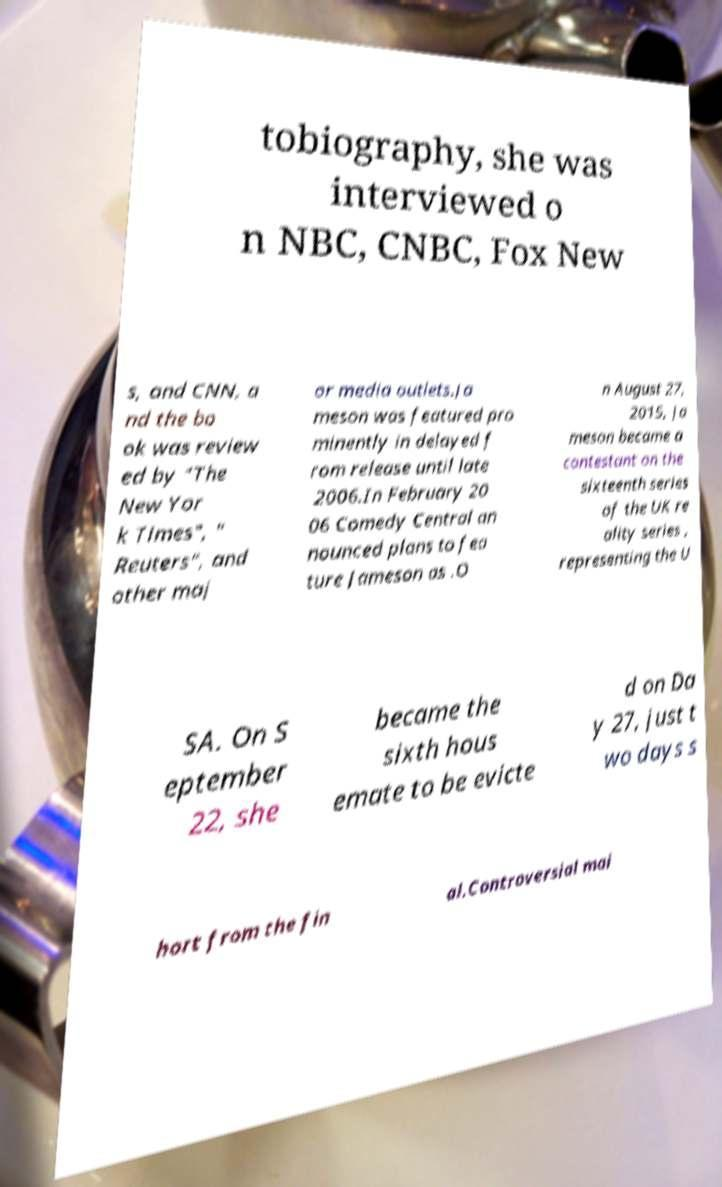Could you extract and type out the text from this image? tobiography, she was interviewed o n NBC, CNBC, Fox New s, and CNN, a nd the bo ok was review ed by "The New Yor k Times", " Reuters", and other maj or media outlets.Ja meson was featured pro minently in delayed f rom release until late 2006.In February 20 06 Comedy Central an nounced plans to fea ture Jameson as .O n August 27, 2015, Ja meson became a contestant on the sixteenth series of the UK re ality series , representing the U SA. On S eptember 22, she became the sixth hous emate to be evicte d on Da y 27, just t wo days s hort from the fin al.Controversial mai 